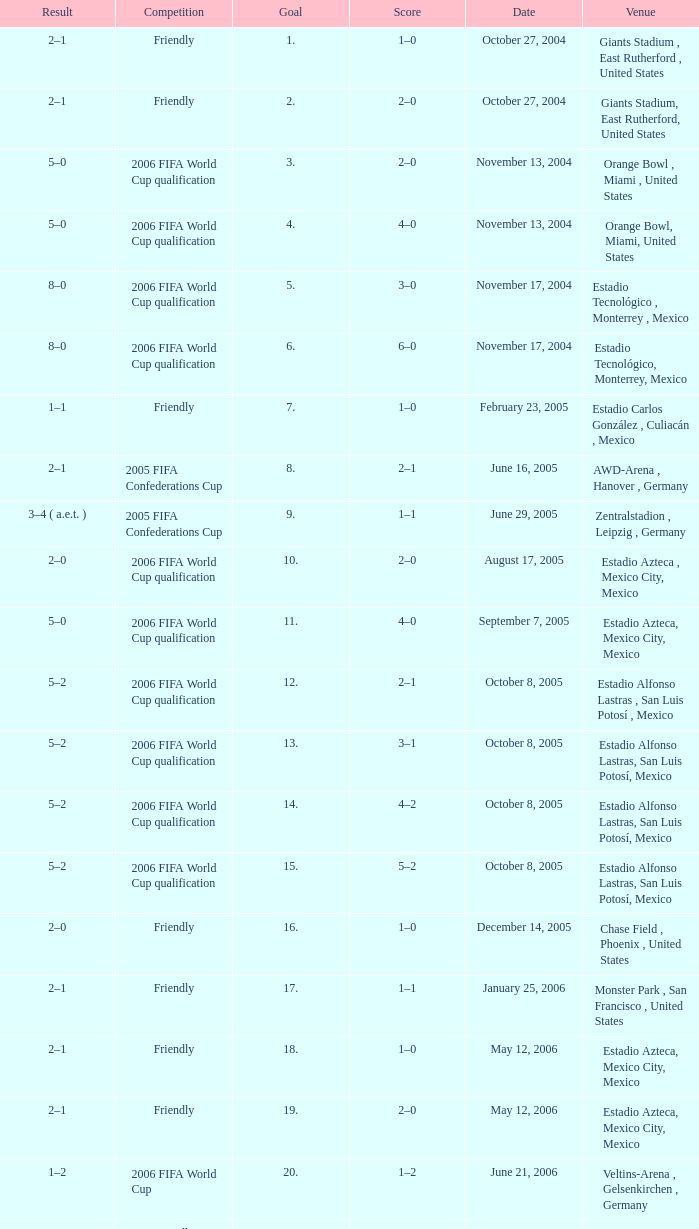Which Competition has a Venue of estadio alfonso lastras, san luis potosí, mexico, and a Goal larger than 15? Friendly. 